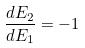Convert formula to latex. <formula><loc_0><loc_0><loc_500><loc_500>\frac { d E _ { 2 } } { d E _ { 1 } } = - 1</formula> 